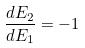Convert formula to latex. <formula><loc_0><loc_0><loc_500><loc_500>\frac { d E _ { 2 } } { d E _ { 1 } } = - 1</formula> 